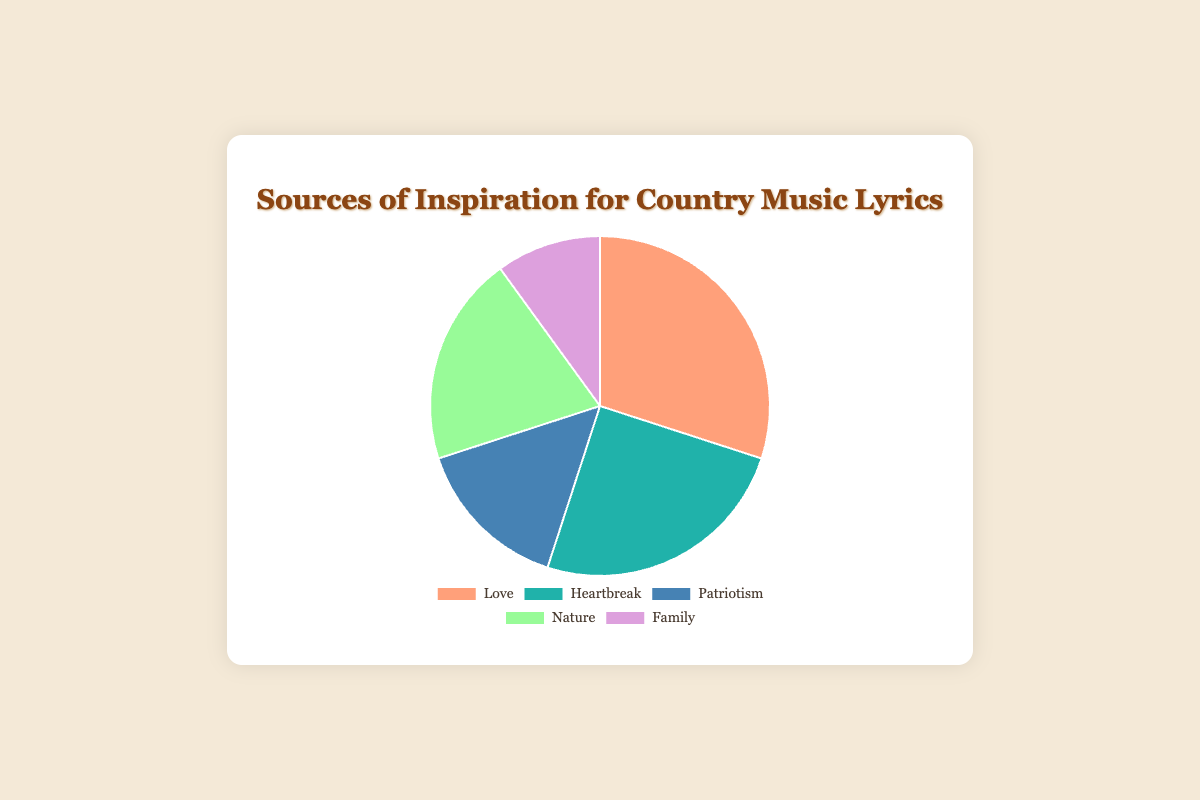Which source of inspiration has the largest percentage? The pie chart shows the contributions of various sources of inspiration, with `Love` having the largest slice at 30%.
Answer: Love Which source has the smallest contribution to country music lyrics? By comparing the sizes of each slice in the pie chart, we see the smallest slice belongs to `Family`, contributing 10%.
Answer: Family What is the combined percentage of `Love` and `Heartbreak`? Adding the percentages of `Love` (30%) and `Heartbreak` (25%) gives 30 + 25 = 55%.
Answer: 55% How much larger is the contribution of `Love` compared to `Family`? Subtracting the percentage of `Family` (10%) from `Love` (30%) gives 30 - 10 = 20%.
Answer: 20% Which categories have a combined percentage equal to that of `Love`? `Nature` (20%) and `Family` (10%) together make 20 + 10 = 30%, which matches `Love`'s percentage.
Answer: Nature and Family Is `Nature` more or less influential than `Patriotism`? Comparing the slices, `Nature` has a 20% contribution whereas `Patriotism` has 15%. Thus, `Nature` is more influential.
Answer: More Which source has the closest contribution to `Heartbreak`? `Nature` with 20% is closest to `Heartbreak`'s 25% when comparing percentages.
Answer: Nature How does the sum of `Patriotism` and `Family` compare to `Nature`? Adding `Patriotism` (15%) to `Family` (10%) gives 15 + 10 = 25%, which is greater than `Nature`'s 20%.
Answer: Greater Identify the contributions that together make up 50% of the sources. `Heartbreak` (25%) and `Nature` (20%) combined give 25 + 20 = 45%, requiring `Family` (10%) to reach 55%, which exceeds 50%. Instead, `Love` (30%) and `Patriotism` (15%) combined give 30 + 15 = 45%, needing 5% more, yet no other source fits. Hence, `Love` (30%) and `Nature` (20%) summing to 30 + 20 = 50%.
Answer: Love and Nature 